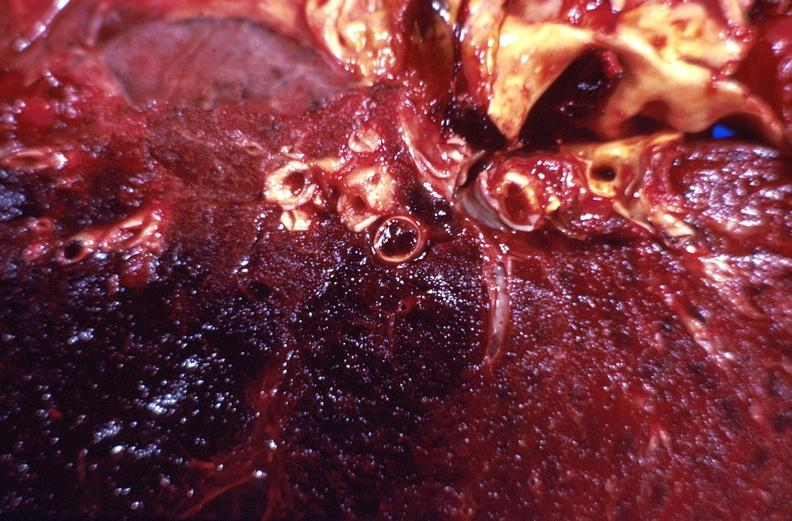what does this image show?
Answer the question using a single word or phrase. Subacute pulmonary thromboembolus with acute infarct 